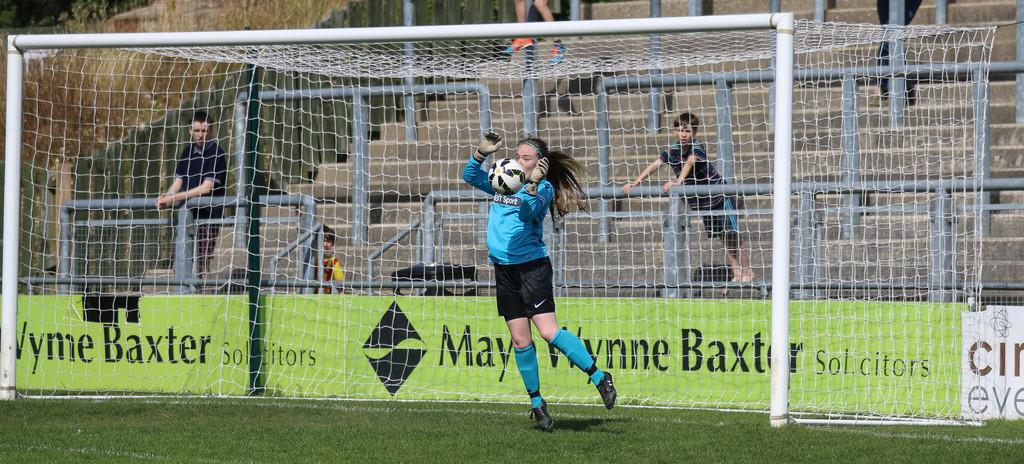Provide a one-sentence caption for the provided image. A soccer goalie blocks the ball in front of an advertisement for Mary Wynne Baxter. 